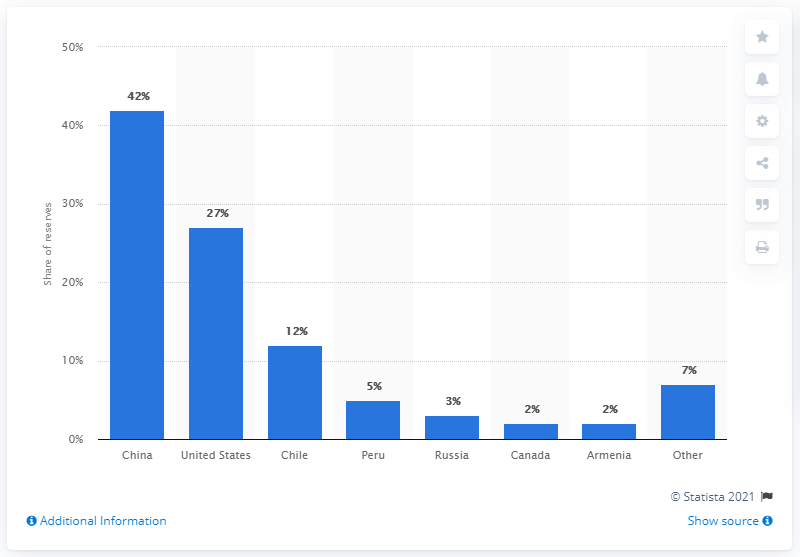What does this chart tell us about global molybdenum reserves? The chart illustrates the distribution of molybdenum reserves worldwide in 2016. It clearly indicates that China was the leading holder of molybdenum reserves, with a 42% share. The United States followed with 27%, then Chile with 12%, and a variety of other countries holding smaller fractions. This data can be useful for understanding the global landscape of molybdenum mining and production. 